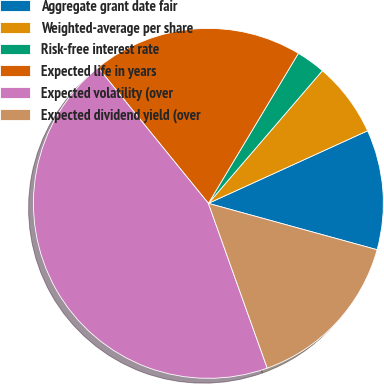<chart> <loc_0><loc_0><loc_500><loc_500><pie_chart><fcel>Aggregate grant date fair<fcel>Weighted-average per share<fcel>Risk-free interest rate<fcel>Expected life in years<fcel>Expected volatility (over<fcel>Expected dividend yield (over<nl><fcel>11.08%<fcel>6.89%<fcel>2.7%<fcel>19.46%<fcel>44.6%<fcel>15.27%<nl></chart> 